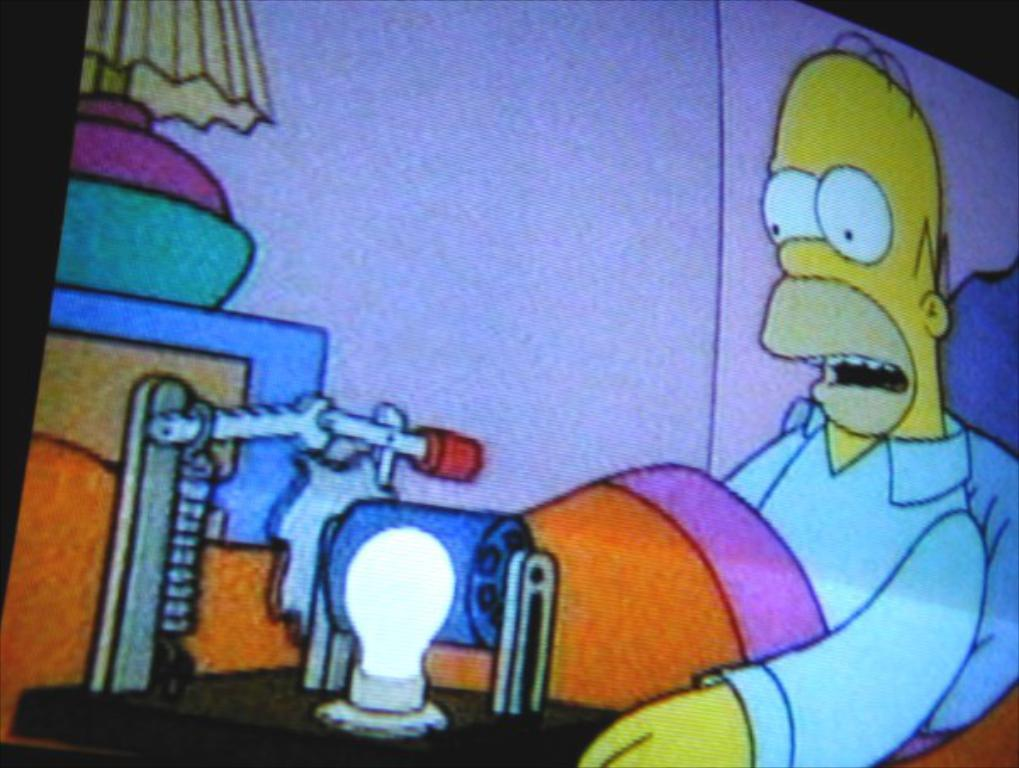What is being displayed on the screen in the image? There is a cartoon show on the screen in the image. How many pizzas are being served in the cartoon show on the screen? There is no information about pizzas in the image, as it only shows a cartoon show on the screen. 